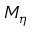Convert formula to latex. <formula><loc_0><loc_0><loc_500><loc_500>M _ { \eta }</formula> 